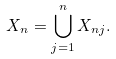Convert formula to latex. <formula><loc_0><loc_0><loc_500><loc_500>X _ { n } = \bigcup _ { j = 1 } ^ { n } X _ { n j } .</formula> 